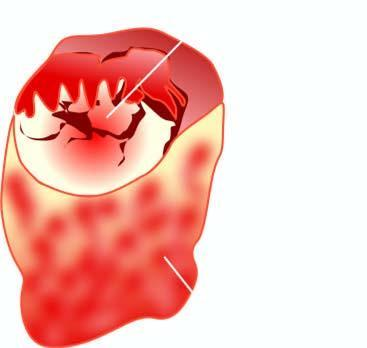does cut surface of the enlarged thyroid gland show a single nodule separated from the rest of thyroid parenchyma by incomplete fibrous septa?
Answer the question using a single word or phrase. Yes 